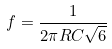Convert formula to latex. <formula><loc_0><loc_0><loc_500><loc_500>f = \frac { 1 } { 2 \pi R C \sqrt { 6 } }</formula> 